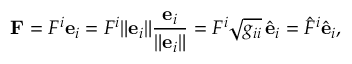<formula> <loc_0><loc_0><loc_500><loc_500>F = F ^ { i } e _ { i } = F ^ { i } { \| { e _ { i } } \| } { \frac { e _ { i } } { \| { e _ { i } } \| } } = F ^ { i } { \sqrt { g _ { i i } } } \, { \hat { e } } _ { i } = { \hat { F } } ^ { i } { \hat { e } } _ { i } ,</formula> 